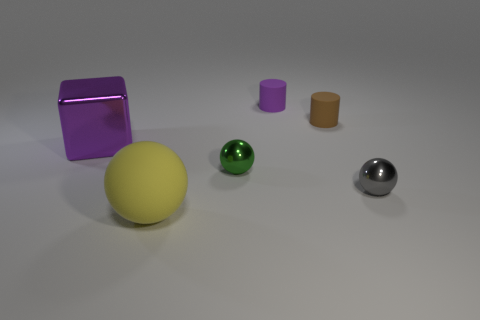Subtract all tiny gray balls. How many balls are left? 2 Add 1 yellow cubes. How many objects exist? 7 Subtract all cubes. How many objects are left? 5 Subtract all matte things. Subtract all big yellow objects. How many objects are left? 2 Add 4 tiny purple matte objects. How many tiny purple matte objects are left? 5 Add 5 yellow spheres. How many yellow spheres exist? 6 Subtract 0 cyan cubes. How many objects are left? 6 